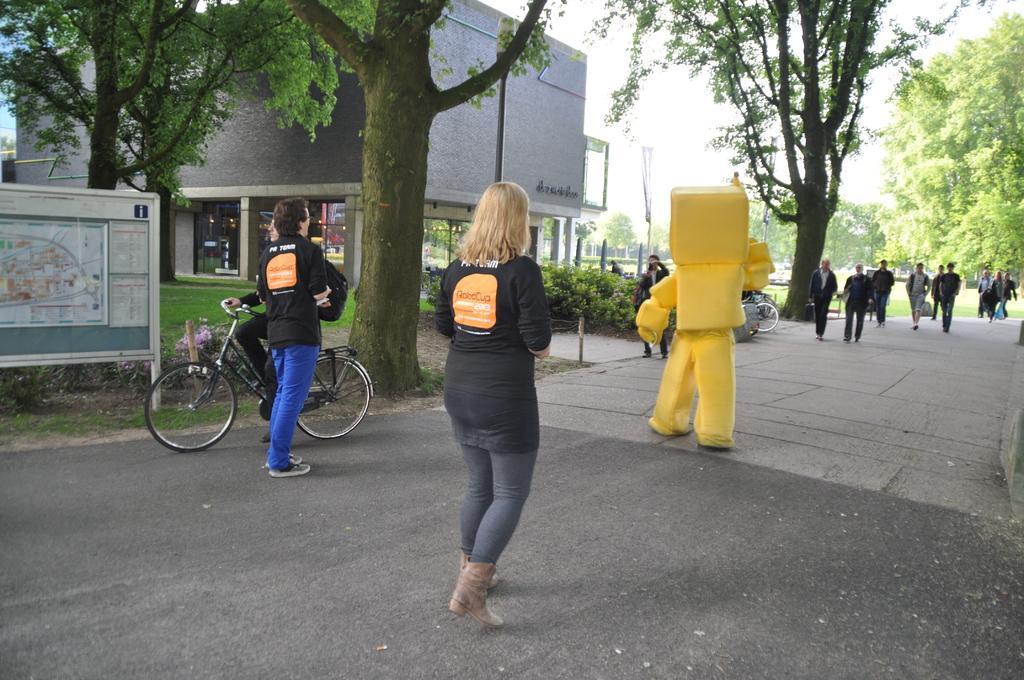Describe this image in one or two sentences. In this picture, we can see a few people among them a person is in a costume, and a few are with bicycle, we can see the ground, road, grass, trees, plants, board with some posters, poles, building with glass doors, and the sky. 